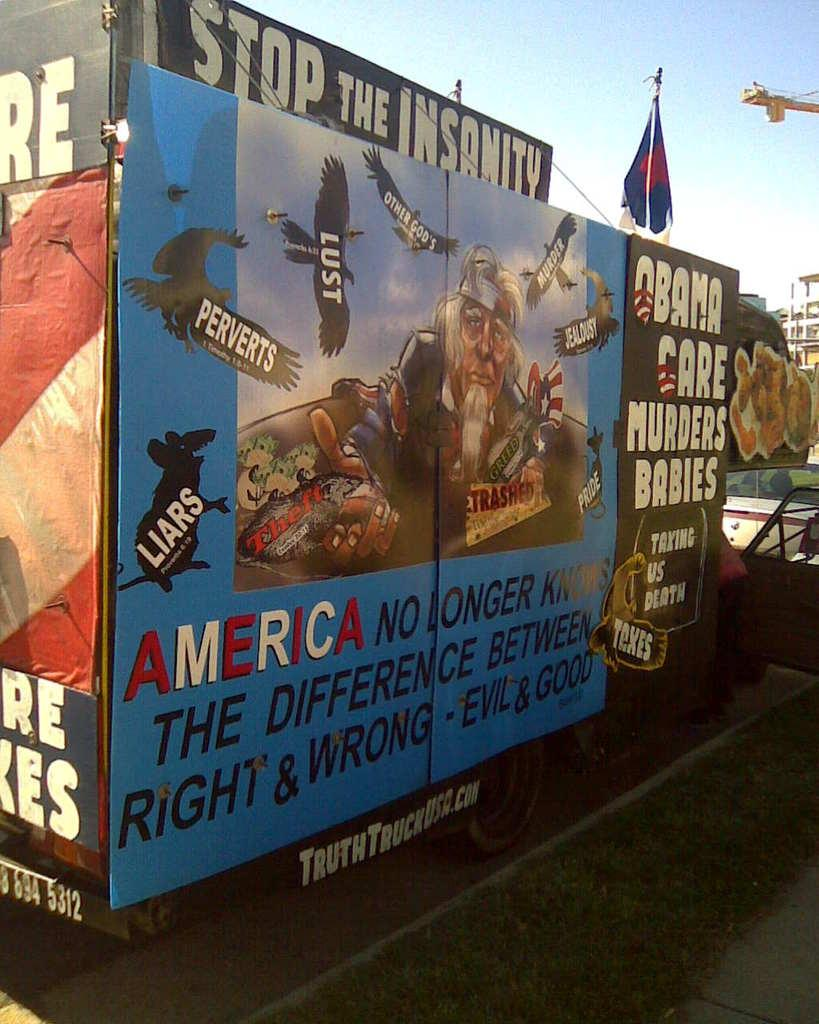Provide a one-sentence caption for the provided image. Political signs cover a sides of a structure, asking that the insanity be stopped. 